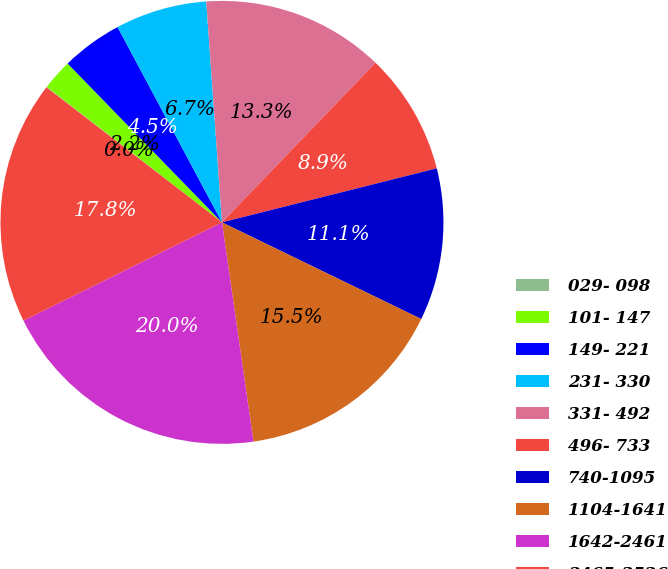Convert chart. <chart><loc_0><loc_0><loc_500><loc_500><pie_chart><fcel>029- 098<fcel>101- 147<fcel>149- 221<fcel>231- 330<fcel>331- 492<fcel>496- 733<fcel>740-1095<fcel>1104-1641<fcel>1642-2461<fcel>2465-3526<nl><fcel>0.04%<fcel>2.25%<fcel>4.46%<fcel>6.68%<fcel>13.32%<fcel>8.89%<fcel>11.11%<fcel>15.54%<fcel>19.96%<fcel>17.75%<nl></chart> 